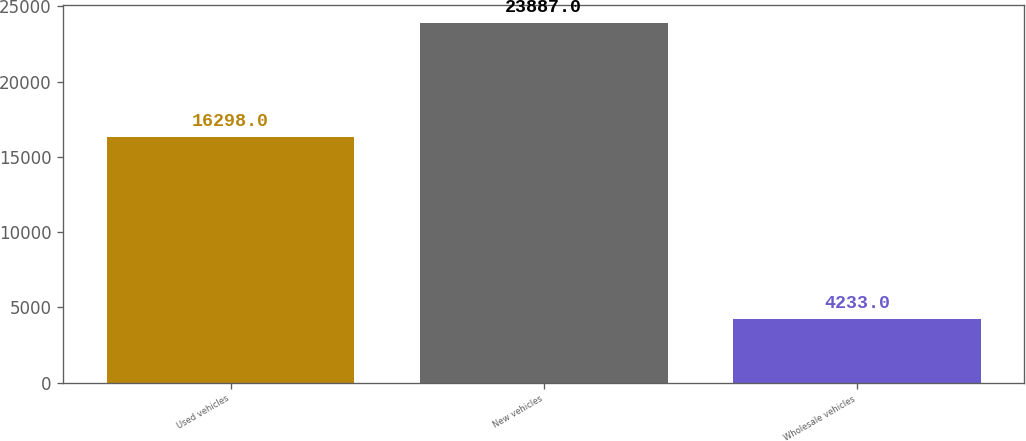<chart> <loc_0><loc_0><loc_500><loc_500><bar_chart><fcel>Used vehicles<fcel>New vehicles<fcel>Wholesale vehicles<nl><fcel>16298<fcel>23887<fcel>4233<nl></chart> 